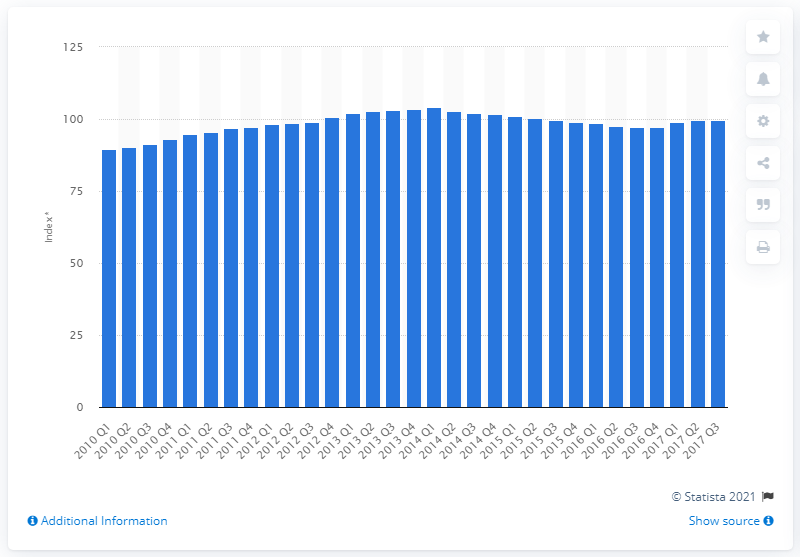Give some essential details in this illustration. According to data from the Bureau of Labor Statistics, the Consumer Price Index (CPI) for food and non-alcoholic beverages in the third quarter of 2017 was 99.7. 